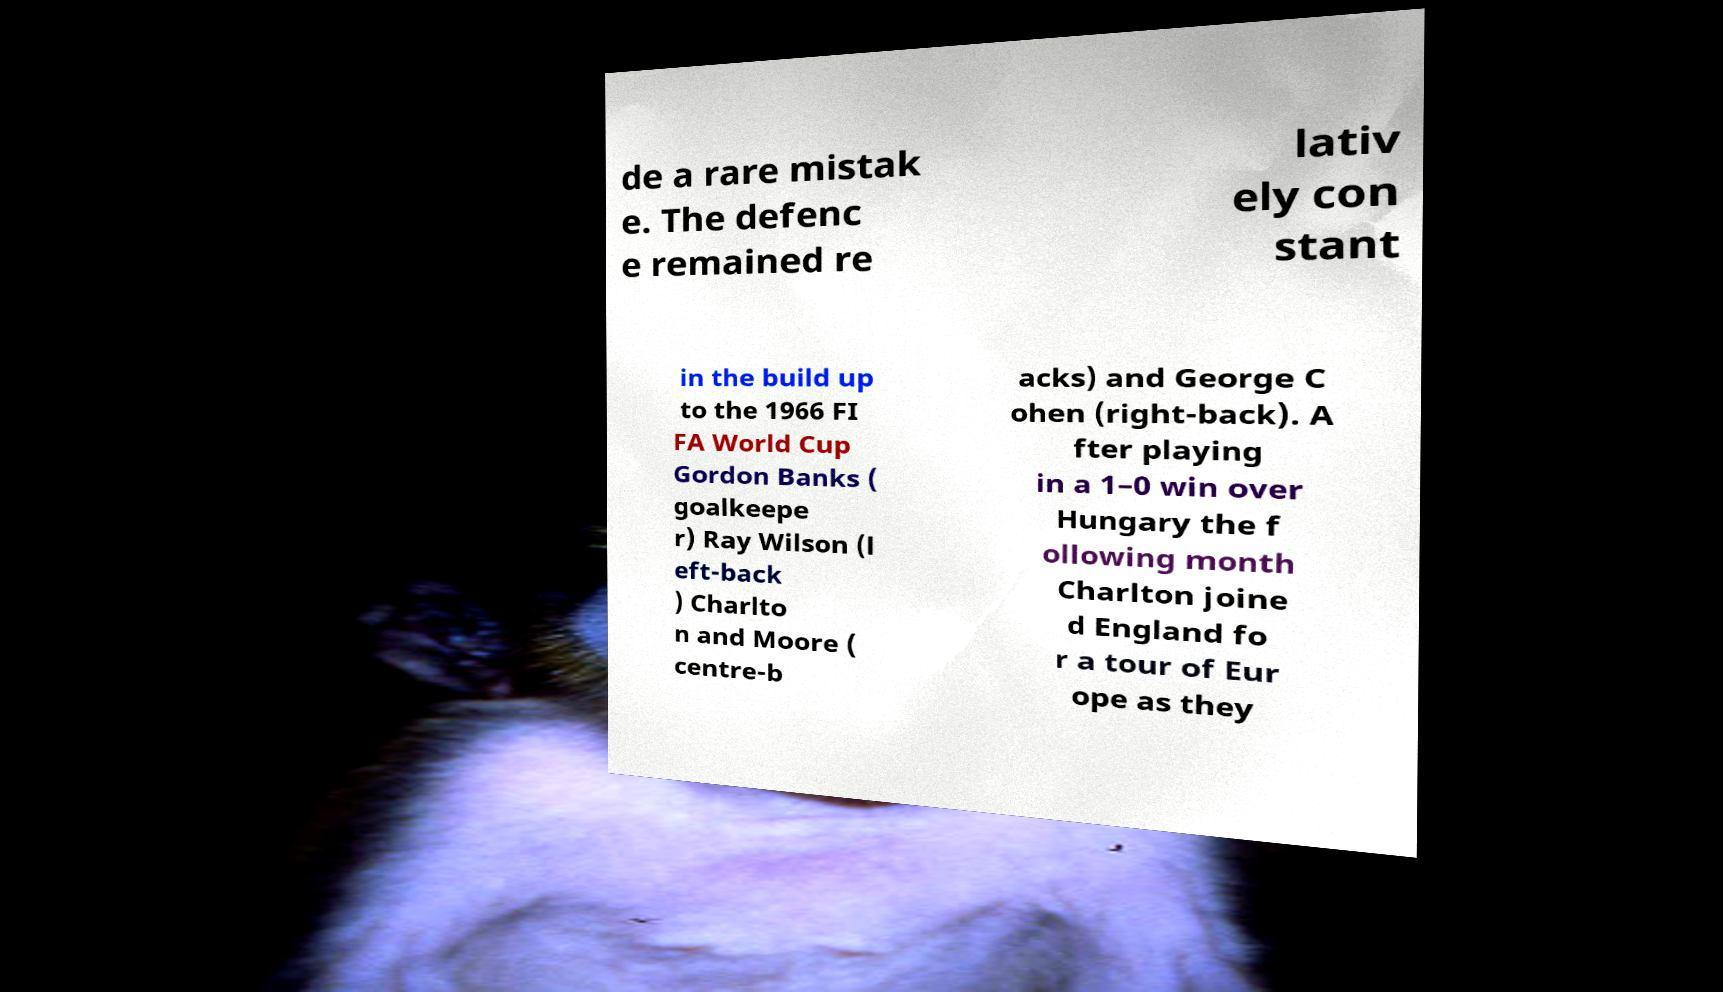For documentation purposes, I need the text within this image transcribed. Could you provide that? de a rare mistak e. The defenc e remained re lativ ely con stant in the build up to the 1966 FI FA World Cup Gordon Banks ( goalkeepe r) Ray Wilson (l eft-back ) Charlto n and Moore ( centre-b acks) and George C ohen (right-back). A fter playing in a 1–0 win over Hungary the f ollowing month Charlton joine d England fo r a tour of Eur ope as they 